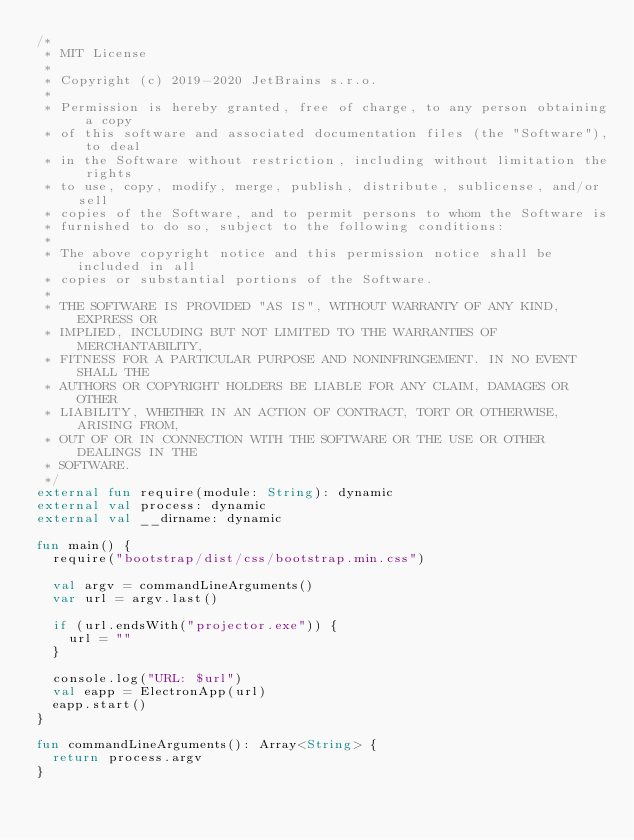<code> <loc_0><loc_0><loc_500><loc_500><_Kotlin_>/*
 * MIT License
 *
 * Copyright (c) 2019-2020 JetBrains s.r.o.
 *
 * Permission is hereby granted, free of charge, to any person obtaining a copy
 * of this software and associated documentation files (the "Software"), to deal
 * in the Software without restriction, including without limitation the rights
 * to use, copy, modify, merge, publish, distribute, sublicense, and/or sell
 * copies of the Software, and to permit persons to whom the Software is
 * furnished to do so, subject to the following conditions:
 *
 * The above copyright notice and this permission notice shall be included in all
 * copies or substantial portions of the Software.
 *
 * THE SOFTWARE IS PROVIDED "AS IS", WITHOUT WARRANTY OF ANY KIND, EXPRESS OR
 * IMPLIED, INCLUDING BUT NOT LIMITED TO THE WARRANTIES OF MERCHANTABILITY,
 * FITNESS FOR A PARTICULAR PURPOSE AND NONINFRINGEMENT. IN NO EVENT SHALL THE
 * AUTHORS OR COPYRIGHT HOLDERS BE LIABLE FOR ANY CLAIM, DAMAGES OR OTHER
 * LIABILITY, WHETHER IN AN ACTION OF CONTRACT, TORT OR OTHERWISE, ARISING FROM,
 * OUT OF OR IN CONNECTION WITH THE SOFTWARE OR THE USE OR OTHER DEALINGS IN THE
 * SOFTWARE.
 */
external fun require(module: String): dynamic
external val process: dynamic
external val __dirname: dynamic

fun main() {
  require("bootstrap/dist/css/bootstrap.min.css")

  val argv = commandLineArguments()
  var url = argv.last()

  if (url.endsWith("projector.exe")) {
    url = ""
  }

  console.log("URL: $url")
  val eapp = ElectronApp(url)
  eapp.start()
}

fun commandLineArguments(): Array<String> {
  return process.argv
}
</code> 